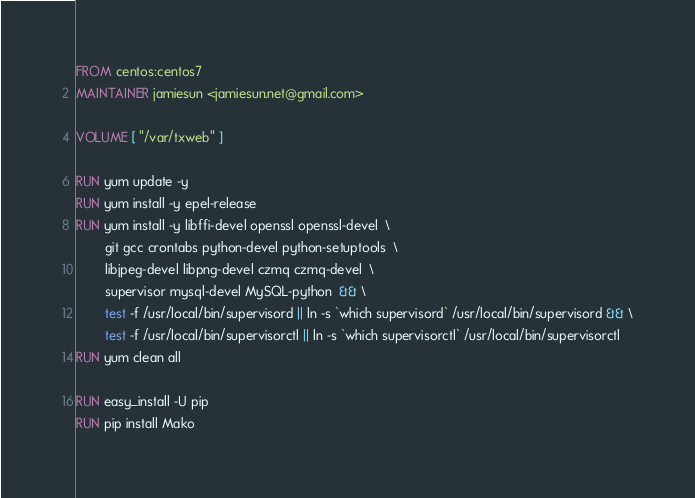Convert code to text. <code><loc_0><loc_0><loc_500><loc_500><_Dockerfile_>FROM centos:centos7
MAINTAINER jamiesun <jamiesun.net@gmail.com>

VOLUME [ "/var/txweb" ]

RUN yum update -y
RUN yum install -y epel-release
RUN yum install -y libffi-devel openssl openssl-devel  \
        git gcc crontabs python-devel python-setuptools  \
        libjpeg-devel libpng-devel czmq czmq-devel  \
        supervisor mysql-devel MySQL-python  && \
        test -f /usr/local/bin/supervisord || ln -s `which supervisord` /usr/local/bin/supervisord && \
        test -f /usr/local/bin/supervisorctl || ln -s `which supervisorctl` /usr/local/bin/supervisorctl 
RUN yum clean all

RUN easy_install -U pip
RUN pip install Mako</code> 